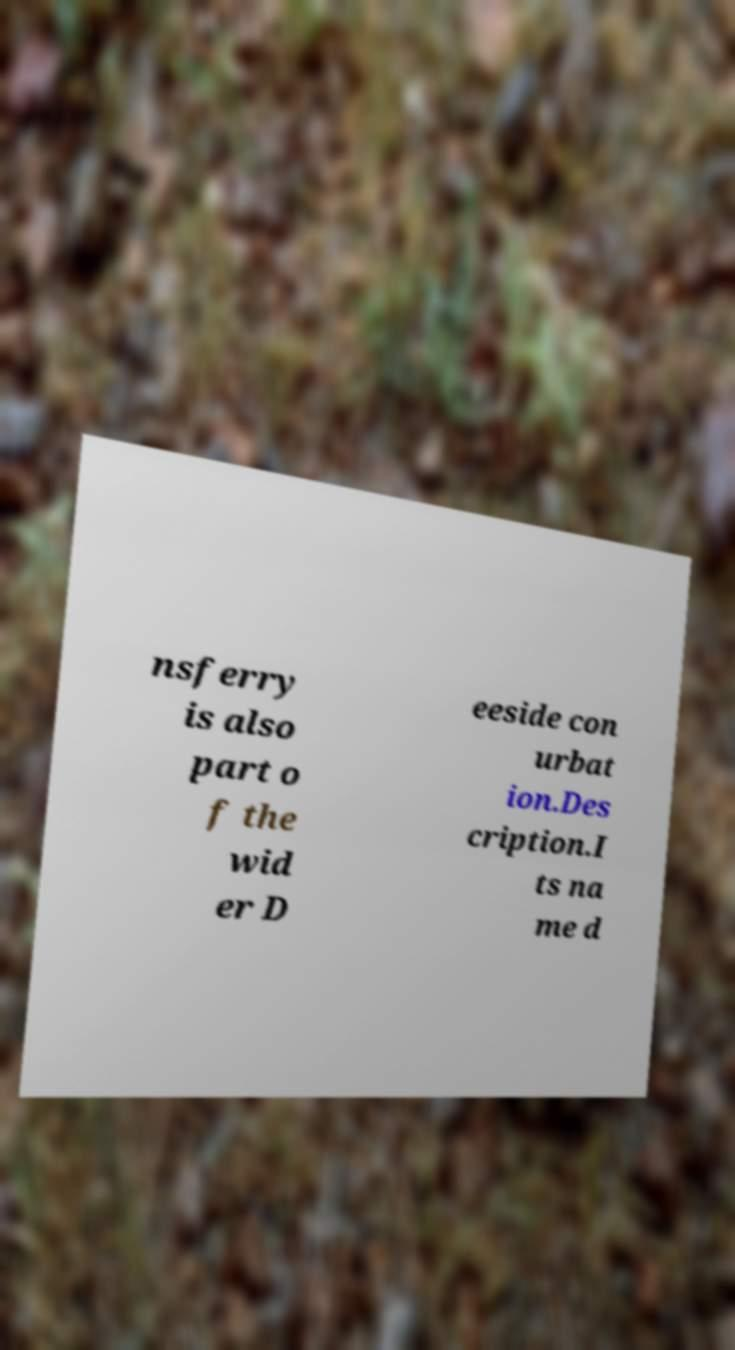I need the written content from this picture converted into text. Can you do that? nsferry is also part o f the wid er D eeside con urbat ion.Des cription.I ts na me d 